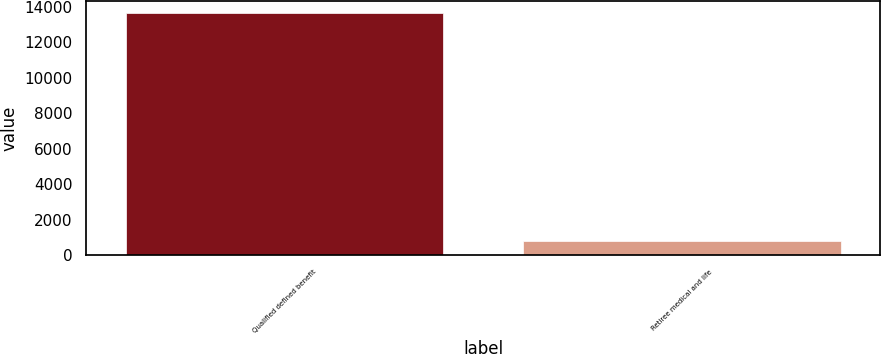Convert chart. <chart><loc_0><loc_0><loc_500><loc_500><bar_chart><fcel>Qualified defined benefit<fcel>Retiree medical and life<nl><fcel>13670<fcel>810<nl></chart> 